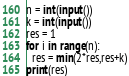Convert code to text. <code><loc_0><loc_0><loc_500><loc_500><_Python_>n = int(input())
k = int(input())
res = 1
for i in range(n):
  res = min(2*res,res+k)
print(res)
</code> 